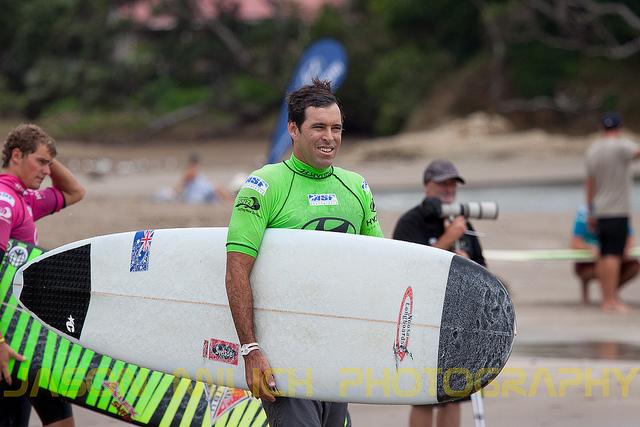Where is this photo taken?
Write a very short answer. Beach. What is the man holding?
Write a very short answer. Surfboard. Is the man surfing?
Give a very brief answer. No. 